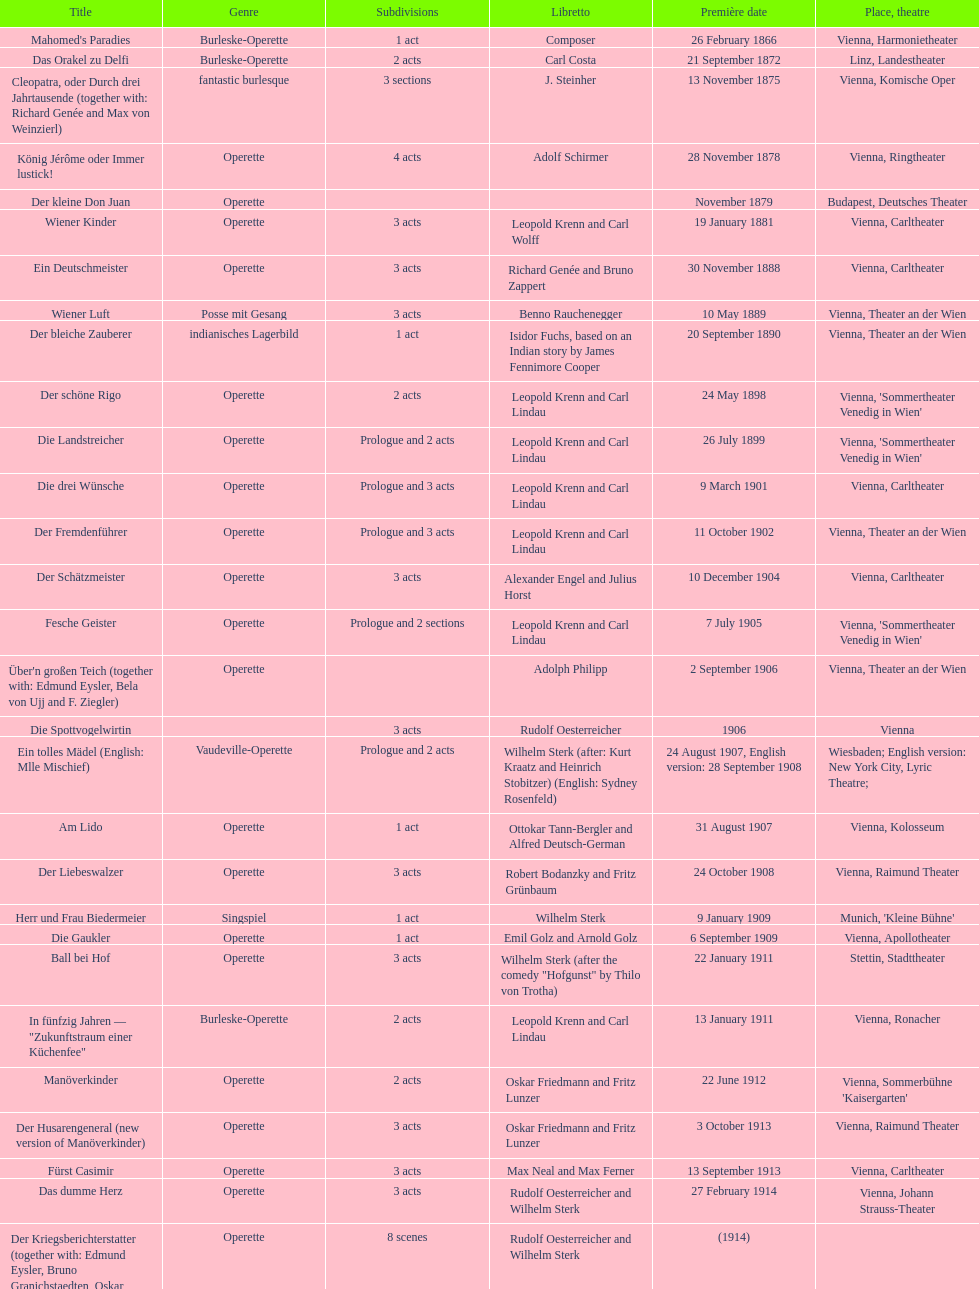How many occurrences of 1 acts existed? 5. 